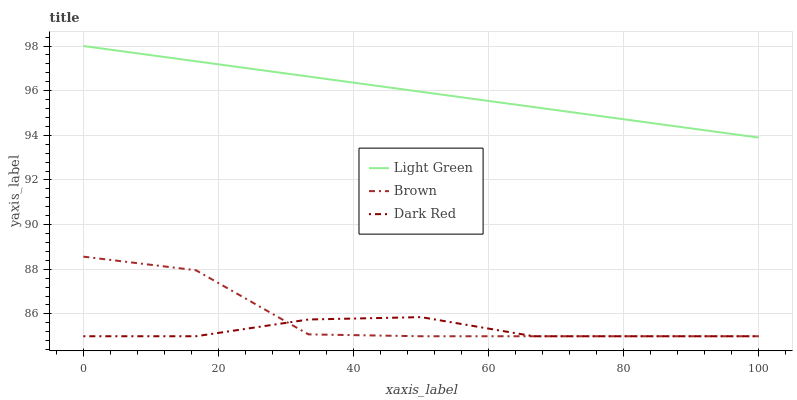Does Dark Red have the minimum area under the curve?
Answer yes or no. Yes. Does Light Green have the maximum area under the curve?
Answer yes or no. Yes. Does Light Green have the minimum area under the curve?
Answer yes or no. No. Does Dark Red have the maximum area under the curve?
Answer yes or no. No. Is Light Green the smoothest?
Answer yes or no. Yes. Is Brown the roughest?
Answer yes or no. Yes. Is Dark Red the smoothest?
Answer yes or no. No. Is Dark Red the roughest?
Answer yes or no. No. Does Brown have the lowest value?
Answer yes or no. Yes. Does Light Green have the lowest value?
Answer yes or no. No. Does Light Green have the highest value?
Answer yes or no. Yes. Does Dark Red have the highest value?
Answer yes or no. No. Is Dark Red less than Light Green?
Answer yes or no. Yes. Is Light Green greater than Brown?
Answer yes or no. Yes. Does Brown intersect Dark Red?
Answer yes or no. Yes. Is Brown less than Dark Red?
Answer yes or no. No. Is Brown greater than Dark Red?
Answer yes or no. No. Does Dark Red intersect Light Green?
Answer yes or no. No. 